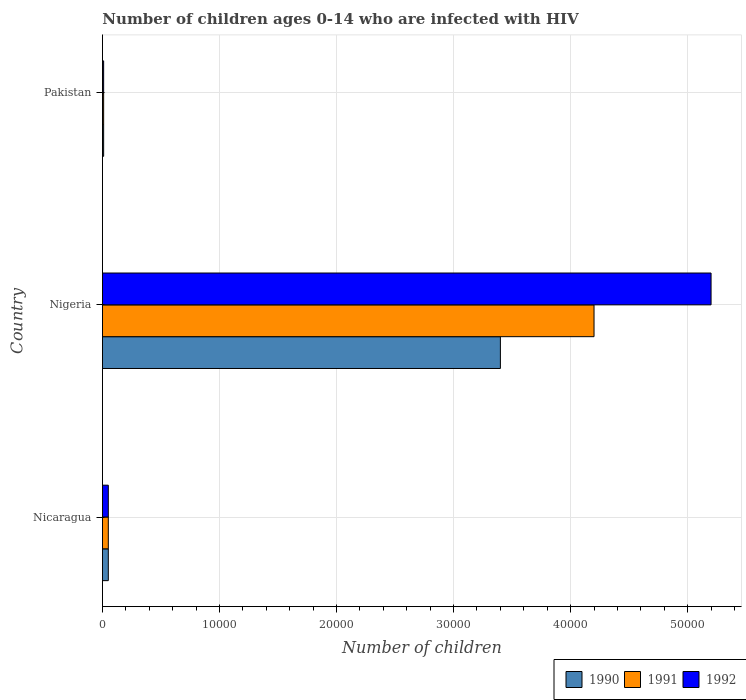How many different coloured bars are there?
Ensure brevity in your answer.  3. How many groups of bars are there?
Ensure brevity in your answer.  3. How many bars are there on the 1st tick from the top?
Offer a terse response. 3. What is the number of HIV infected children in 1992 in Nigeria?
Ensure brevity in your answer.  5.20e+04. Across all countries, what is the maximum number of HIV infected children in 1990?
Ensure brevity in your answer.  3.40e+04. Across all countries, what is the minimum number of HIV infected children in 1990?
Offer a terse response. 100. In which country was the number of HIV infected children in 1991 maximum?
Offer a terse response. Nigeria. What is the total number of HIV infected children in 1991 in the graph?
Keep it short and to the point. 4.26e+04. What is the difference between the number of HIV infected children in 1992 in Nicaragua and that in Nigeria?
Your answer should be very brief. -5.15e+04. What is the difference between the number of HIV infected children in 1992 in Nicaragua and the number of HIV infected children in 1990 in Pakistan?
Ensure brevity in your answer.  400. What is the average number of HIV infected children in 1990 per country?
Keep it short and to the point. 1.15e+04. What is the difference between the number of HIV infected children in 1990 and number of HIV infected children in 1992 in Nigeria?
Your answer should be compact. -1.80e+04. In how many countries, is the number of HIV infected children in 1992 greater than 42000 ?
Your response must be concise. 1. Is the difference between the number of HIV infected children in 1990 in Nicaragua and Nigeria greater than the difference between the number of HIV infected children in 1992 in Nicaragua and Nigeria?
Offer a very short reply. Yes. What is the difference between the highest and the second highest number of HIV infected children in 1991?
Offer a very short reply. 4.15e+04. What is the difference between the highest and the lowest number of HIV infected children in 1992?
Your response must be concise. 5.19e+04. Is the sum of the number of HIV infected children in 1990 in Nigeria and Pakistan greater than the maximum number of HIV infected children in 1991 across all countries?
Offer a very short reply. No. Is it the case that in every country, the sum of the number of HIV infected children in 1991 and number of HIV infected children in 1992 is greater than the number of HIV infected children in 1990?
Offer a terse response. Yes. How many countries are there in the graph?
Your answer should be very brief. 3. Are the values on the major ticks of X-axis written in scientific E-notation?
Your response must be concise. No. Does the graph contain grids?
Your answer should be compact. Yes. How many legend labels are there?
Your answer should be compact. 3. How are the legend labels stacked?
Your response must be concise. Horizontal. What is the title of the graph?
Your answer should be compact. Number of children ages 0-14 who are infected with HIV. Does "1982" appear as one of the legend labels in the graph?
Your response must be concise. No. What is the label or title of the X-axis?
Provide a succinct answer. Number of children. What is the label or title of the Y-axis?
Your answer should be compact. Country. What is the Number of children of 1991 in Nicaragua?
Give a very brief answer. 500. What is the Number of children of 1990 in Nigeria?
Offer a very short reply. 3.40e+04. What is the Number of children of 1991 in Nigeria?
Offer a terse response. 4.20e+04. What is the Number of children of 1992 in Nigeria?
Your answer should be very brief. 5.20e+04. What is the Number of children in 1990 in Pakistan?
Your answer should be compact. 100. Across all countries, what is the maximum Number of children in 1990?
Your response must be concise. 3.40e+04. Across all countries, what is the maximum Number of children of 1991?
Give a very brief answer. 4.20e+04. Across all countries, what is the maximum Number of children in 1992?
Offer a terse response. 5.20e+04. Across all countries, what is the minimum Number of children in 1991?
Your answer should be very brief. 100. Across all countries, what is the minimum Number of children in 1992?
Your response must be concise. 100. What is the total Number of children of 1990 in the graph?
Your answer should be compact. 3.46e+04. What is the total Number of children of 1991 in the graph?
Your response must be concise. 4.26e+04. What is the total Number of children in 1992 in the graph?
Offer a terse response. 5.26e+04. What is the difference between the Number of children of 1990 in Nicaragua and that in Nigeria?
Your response must be concise. -3.35e+04. What is the difference between the Number of children of 1991 in Nicaragua and that in Nigeria?
Your response must be concise. -4.15e+04. What is the difference between the Number of children of 1992 in Nicaragua and that in Nigeria?
Keep it short and to the point. -5.15e+04. What is the difference between the Number of children in 1992 in Nicaragua and that in Pakistan?
Offer a very short reply. 400. What is the difference between the Number of children in 1990 in Nigeria and that in Pakistan?
Your response must be concise. 3.39e+04. What is the difference between the Number of children of 1991 in Nigeria and that in Pakistan?
Provide a short and direct response. 4.19e+04. What is the difference between the Number of children of 1992 in Nigeria and that in Pakistan?
Provide a short and direct response. 5.19e+04. What is the difference between the Number of children of 1990 in Nicaragua and the Number of children of 1991 in Nigeria?
Offer a terse response. -4.15e+04. What is the difference between the Number of children in 1990 in Nicaragua and the Number of children in 1992 in Nigeria?
Offer a very short reply. -5.15e+04. What is the difference between the Number of children of 1991 in Nicaragua and the Number of children of 1992 in Nigeria?
Provide a short and direct response. -5.15e+04. What is the difference between the Number of children of 1990 in Nicaragua and the Number of children of 1991 in Pakistan?
Your answer should be compact. 400. What is the difference between the Number of children of 1990 in Nicaragua and the Number of children of 1992 in Pakistan?
Your answer should be compact. 400. What is the difference between the Number of children in 1990 in Nigeria and the Number of children in 1991 in Pakistan?
Offer a terse response. 3.39e+04. What is the difference between the Number of children in 1990 in Nigeria and the Number of children in 1992 in Pakistan?
Keep it short and to the point. 3.39e+04. What is the difference between the Number of children in 1991 in Nigeria and the Number of children in 1992 in Pakistan?
Offer a terse response. 4.19e+04. What is the average Number of children of 1990 per country?
Make the answer very short. 1.15e+04. What is the average Number of children in 1991 per country?
Offer a terse response. 1.42e+04. What is the average Number of children in 1992 per country?
Your answer should be very brief. 1.75e+04. What is the difference between the Number of children in 1990 and Number of children in 1991 in Nicaragua?
Make the answer very short. 0. What is the difference between the Number of children of 1991 and Number of children of 1992 in Nicaragua?
Your answer should be compact. 0. What is the difference between the Number of children of 1990 and Number of children of 1991 in Nigeria?
Offer a very short reply. -8000. What is the difference between the Number of children of 1990 and Number of children of 1992 in Nigeria?
Keep it short and to the point. -1.80e+04. What is the difference between the Number of children in 1990 and Number of children in 1992 in Pakistan?
Your answer should be compact. 0. What is the ratio of the Number of children of 1990 in Nicaragua to that in Nigeria?
Offer a very short reply. 0.01. What is the ratio of the Number of children in 1991 in Nicaragua to that in Nigeria?
Offer a very short reply. 0.01. What is the ratio of the Number of children of 1992 in Nicaragua to that in Nigeria?
Provide a succinct answer. 0.01. What is the ratio of the Number of children of 1990 in Nicaragua to that in Pakistan?
Provide a short and direct response. 5. What is the ratio of the Number of children in 1991 in Nicaragua to that in Pakistan?
Provide a succinct answer. 5. What is the ratio of the Number of children of 1992 in Nicaragua to that in Pakistan?
Your answer should be compact. 5. What is the ratio of the Number of children in 1990 in Nigeria to that in Pakistan?
Provide a succinct answer. 340. What is the ratio of the Number of children of 1991 in Nigeria to that in Pakistan?
Ensure brevity in your answer.  420. What is the ratio of the Number of children in 1992 in Nigeria to that in Pakistan?
Offer a terse response. 520. What is the difference between the highest and the second highest Number of children of 1990?
Offer a terse response. 3.35e+04. What is the difference between the highest and the second highest Number of children of 1991?
Provide a short and direct response. 4.15e+04. What is the difference between the highest and the second highest Number of children in 1992?
Give a very brief answer. 5.15e+04. What is the difference between the highest and the lowest Number of children in 1990?
Provide a short and direct response. 3.39e+04. What is the difference between the highest and the lowest Number of children of 1991?
Your response must be concise. 4.19e+04. What is the difference between the highest and the lowest Number of children in 1992?
Give a very brief answer. 5.19e+04. 